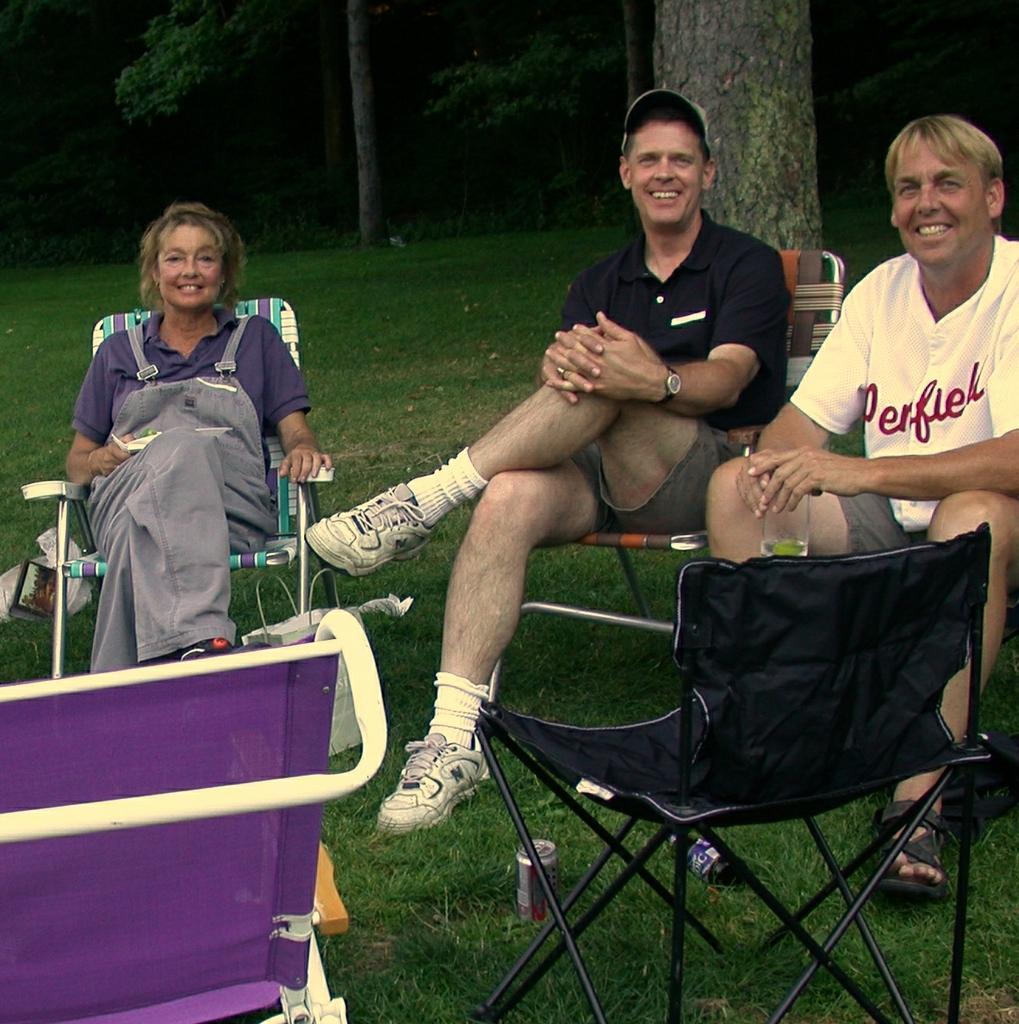Can you describe this image briefly? In this image i can see a woman and two man sitting on the a chair there are two other chairs in front of them and two canes on the floor at the background i can see a tree. 